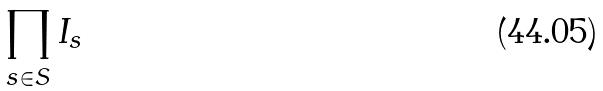<formula> <loc_0><loc_0><loc_500><loc_500>\prod _ { s \in S } I _ { s }</formula> 